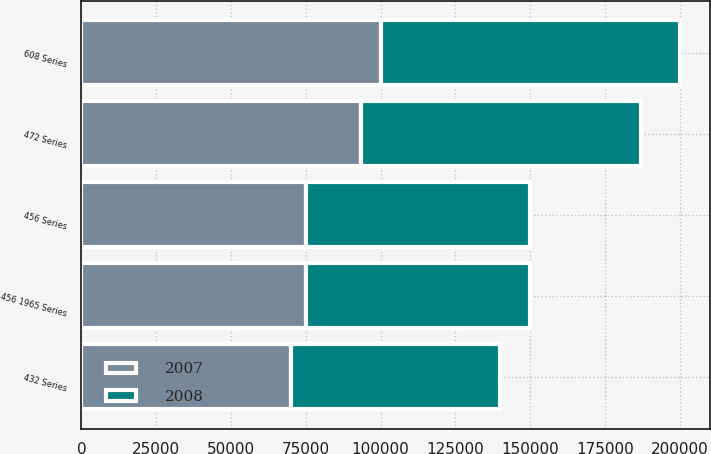Convert chart. <chart><loc_0><loc_0><loc_500><loc_500><stacked_bar_chart><ecel><fcel>432 Series<fcel>472 Series<fcel>456 Series<fcel>456 1965 Series<fcel>608 Series<nl><fcel>2007<fcel>70000<fcel>93500<fcel>75000<fcel>75000<fcel>100000<nl><fcel>2008<fcel>70000<fcel>93500<fcel>75000<fcel>75000<fcel>100000<nl></chart> 